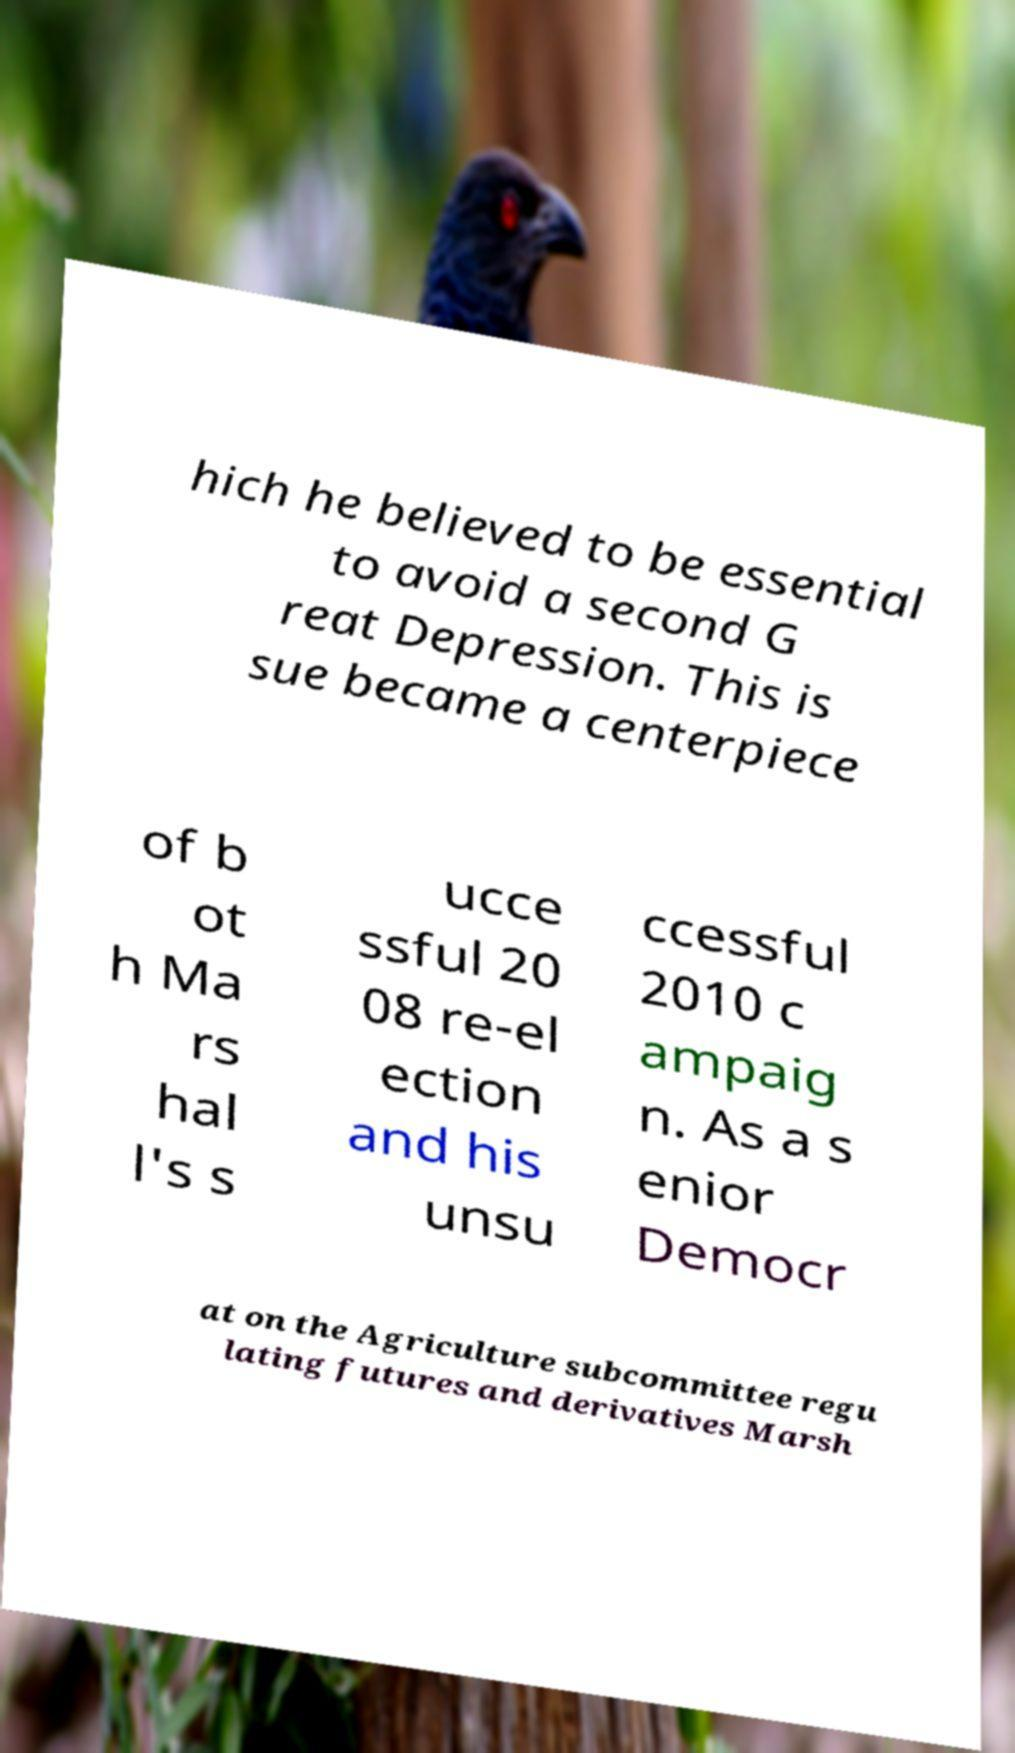Please read and relay the text visible in this image. What does it say? hich he believed to be essential to avoid a second G reat Depression. This is sue became a centerpiece of b ot h Ma rs hal l's s ucce ssful 20 08 re-el ection and his unsu ccessful 2010 c ampaig n. As a s enior Democr at on the Agriculture subcommittee regu lating futures and derivatives Marsh 